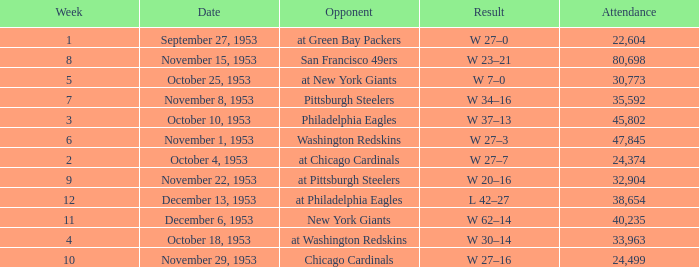What is the largest crowd size at a match against the Chicago Cardinals after Week 10 of the season? None. 